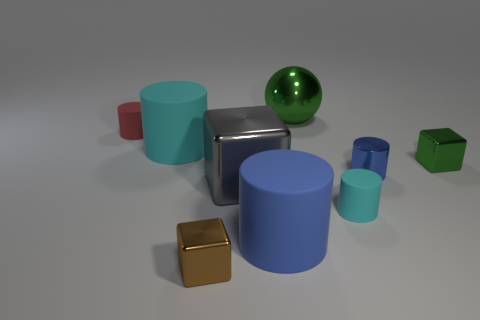Add 1 gray rubber balls. How many objects exist? 10 Subtract all cyan rubber cylinders. How many cylinders are left? 3 Subtract all cyan blocks. How many cyan cylinders are left? 2 Subtract 3 blocks. How many blocks are left? 0 Subtract all red cylinders. How many cylinders are left? 4 Subtract all cubes. How many objects are left? 6 Subtract 0 cyan spheres. How many objects are left? 9 Subtract all blue cylinders. Subtract all brown blocks. How many cylinders are left? 3 Subtract all large blue matte things. Subtract all small metallic blocks. How many objects are left? 6 Add 9 large green metallic things. How many large green metallic things are left? 10 